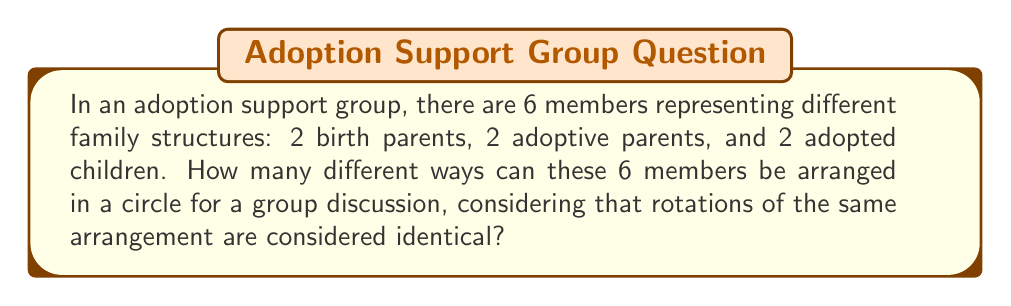Teach me how to tackle this problem. Let's approach this step-by-step:

1) First, we need to consider that this is a circular permutation problem. In circular permutations, rotations of the same arrangement are considered identical.

2) The formula for circular permutations of $n$ distinct objects is:

   $$(n-1)!$$

3) However, in this case, we don't have 6 distinct objects. We have:
   - 2 birth parents (indistinguishable from each other)
   - 2 adoptive parents (indistinguishable from each other)
   - 2 adopted children (indistinguishable from each other)

4) To account for this, we need to divide by the number of permutations within each group:

   $$\frac{(6-1)!}{2! \cdot 2! \cdot 2!}$$

5) Let's calculate this:
   
   $$\frac{5!}{2! \cdot 2! \cdot 2!} = \frac{120}{8} = 15$$

This result represents the number of unique circular arrangements, taking into account the indistinguishability within each group and the circular nature of the arrangement.
Answer: 15 unique circular arrangements 